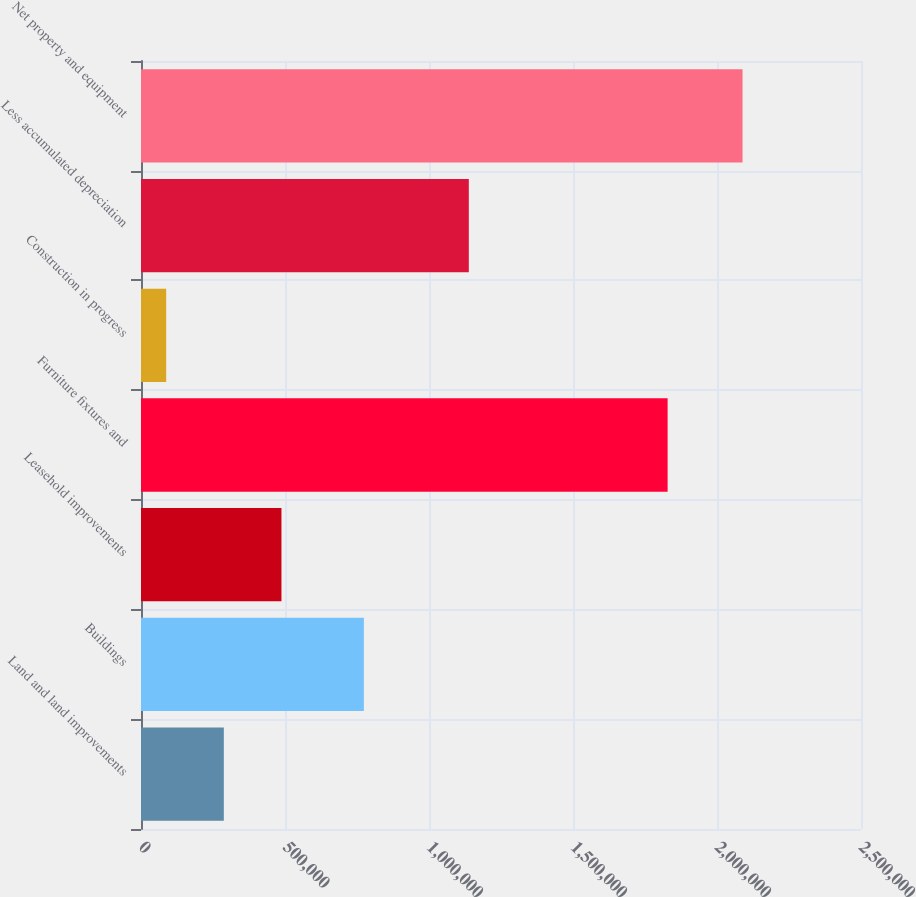Convert chart. <chart><loc_0><loc_0><loc_500><loc_500><bar_chart><fcel>Land and land improvements<fcel>Buildings<fcel>Leasehold improvements<fcel>Furniture fixtures and<fcel>Construction in progress<fcel>Less accumulated depreciation<fcel>Net property and equipment<nl><fcel>287566<fcel>773835<fcel>487688<fcel>1.82857e+06<fcel>87444<fcel>1.13823e+06<fcel>2.08866e+06<nl></chart> 